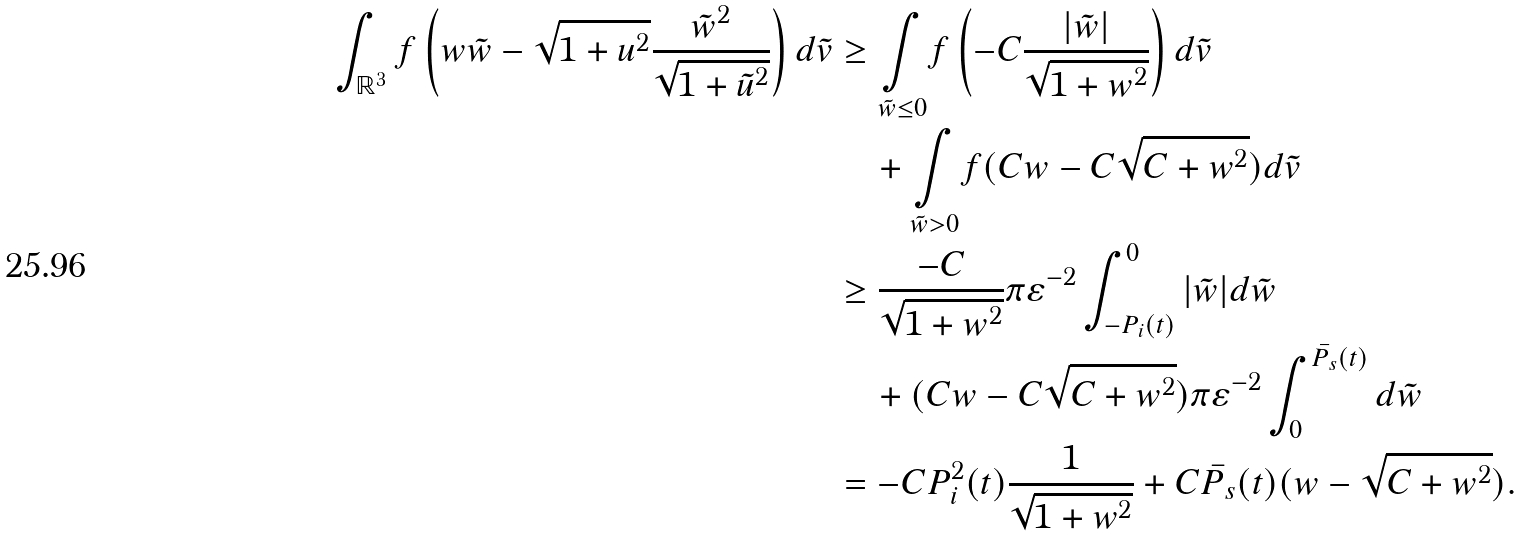<formula> <loc_0><loc_0><loc_500><loc_500>\int _ { \mathbb { R } ^ { 3 } } f \left ( w \tilde { w } - \sqrt { 1 + u ^ { 2 } } \frac { \tilde { w } ^ { 2 } } { \sqrt { 1 + \tilde { u } ^ { 2 } } } \right ) d \tilde { v } & \geq \underset { \tilde { w } \leq 0 } { \int } f \left ( - C \frac { | \tilde { w } | } { \sqrt { 1 + w ^ { 2 } } } \right ) d \tilde { v } \\ & \quad + \underset { \tilde { w } > 0 } { \int } f ( C w - C \sqrt { C + w ^ { 2 } } ) d \tilde { v } \\ & \geq \frac { - C } { \sqrt { 1 + w ^ { 2 } } } \pi \varepsilon ^ { - 2 } \int _ { - P _ { i } ( t ) } ^ { 0 } | \tilde { w } | d \tilde { w } \\ & \quad + ( C w - C \sqrt { C + w ^ { 2 } } ) \pi \varepsilon ^ { - 2 } \int _ { 0 } ^ { \bar { P _ { s } } ( t ) } d \tilde { w } \\ & = - C P _ { i } ^ { 2 } ( t ) \frac { 1 } { \sqrt { 1 + w ^ { 2 } } } + C \bar { P _ { s } } ( t ) ( w - \sqrt { C + w ^ { 2 } } ) .</formula> 